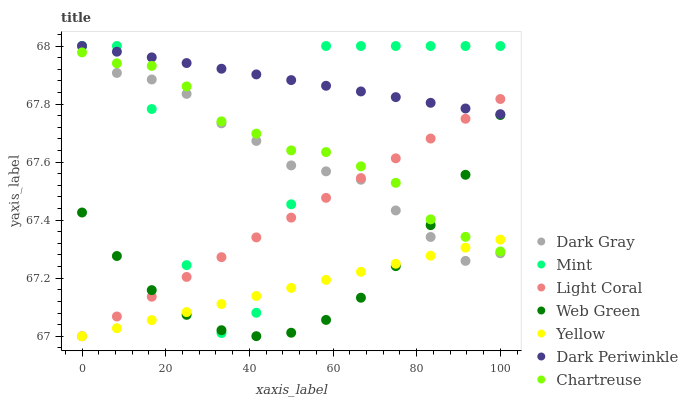Does Yellow have the minimum area under the curve?
Answer yes or no. Yes. Does Dark Periwinkle have the maximum area under the curve?
Answer yes or no. Yes. Does Dark Gray have the minimum area under the curve?
Answer yes or no. No. Does Dark Gray have the maximum area under the curve?
Answer yes or no. No. Is Dark Periwinkle the smoothest?
Answer yes or no. Yes. Is Mint the roughest?
Answer yes or no. Yes. Is Yellow the smoothest?
Answer yes or no. No. Is Yellow the roughest?
Answer yes or no. No. Does Light Coral have the lowest value?
Answer yes or no. Yes. Does Dark Gray have the lowest value?
Answer yes or no. No. Does Dark Periwinkle have the highest value?
Answer yes or no. Yes. Does Yellow have the highest value?
Answer yes or no. No. Is Yellow less than Dark Periwinkle?
Answer yes or no. Yes. Is Dark Periwinkle greater than Yellow?
Answer yes or no. Yes. Does Chartreuse intersect Dark Gray?
Answer yes or no. Yes. Is Chartreuse less than Dark Gray?
Answer yes or no. No. Is Chartreuse greater than Dark Gray?
Answer yes or no. No. Does Yellow intersect Dark Periwinkle?
Answer yes or no. No. 